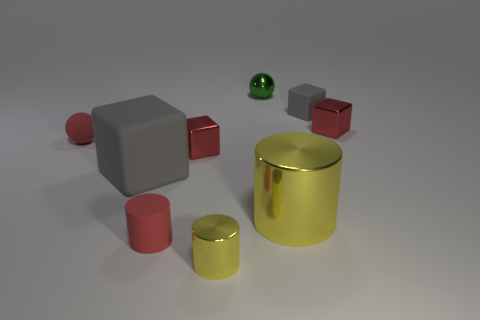Subtract all tiny gray matte cubes. How many cubes are left? 3 Subtract all cylinders. How many objects are left? 6 Add 1 gray cubes. How many objects exist? 10 Subtract all red cylinders. How many cylinders are left? 2 Subtract 0 purple blocks. How many objects are left? 9 Subtract 3 cubes. How many cubes are left? 1 Subtract all purple spheres. Subtract all cyan blocks. How many spheres are left? 2 Subtract all red cubes. How many blue cylinders are left? 0 Subtract all big brown metal spheres. Subtract all red shiny objects. How many objects are left? 7 Add 5 small red rubber things. How many small red rubber things are left? 7 